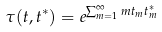<formula> <loc_0><loc_0><loc_500><loc_500>\tau ( { t } , { t } ^ { * } ) = e ^ { \sum _ { m = 1 } ^ { \infty } m t _ { m } t _ { m } ^ { * } }</formula> 